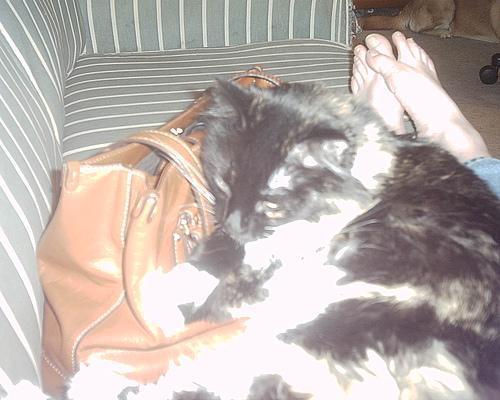Where does the cat rest?
Make your selection from the four choices given to correctly answer the question.
Options: Cat house, couch, mattress, dog house. Couch. 